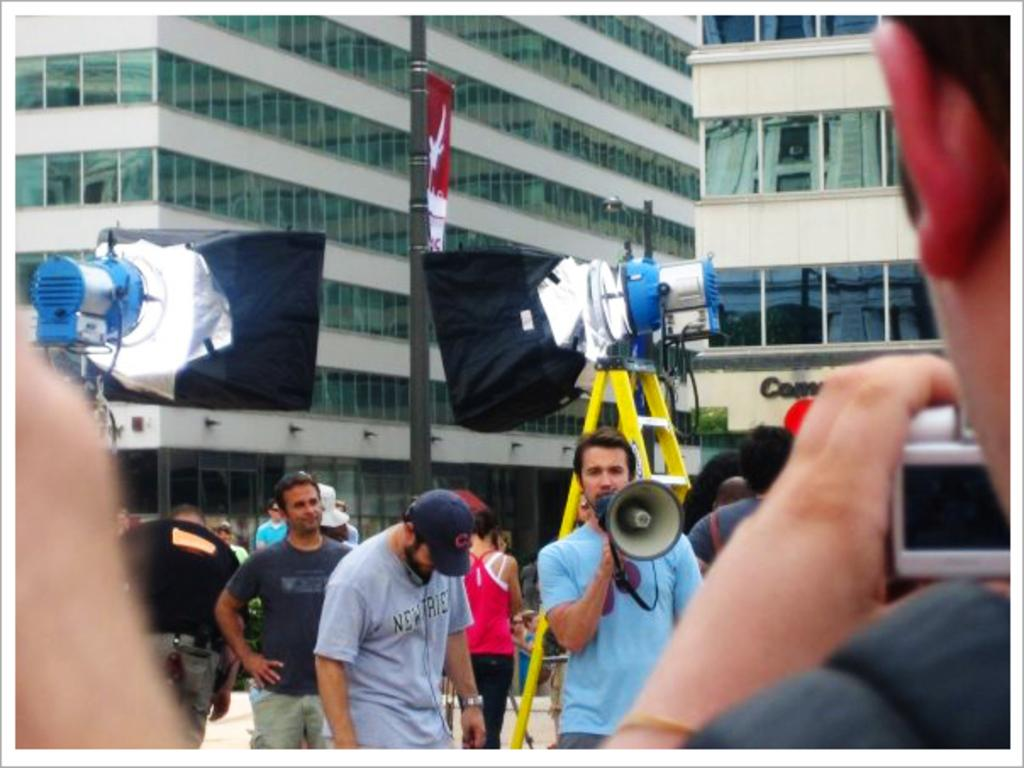What type of structures can be seen in the image? There are buildings in the image. Are there any people present in the image? Yes, there are persons standing in the image. Can you describe the person holding a speaker? There is a person holding a speaker in the image. What else can be seen in the image besides buildings and people? There are stands in the image. What type of punishment is being administered to the rat in the image? There is no rat present in the image, and therefore no punishment is being administered. What type of produce can be seen in the image? There is no produce visible in the image. 